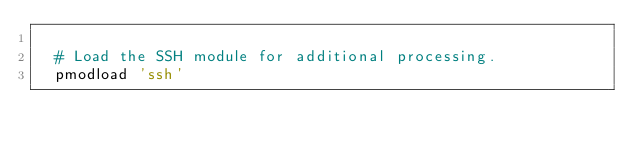Convert code to text. <code><loc_0><loc_0><loc_500><loc_500><_Bash_>
  # Load the SSH module for additional processing.
  pmodload 'ssh'
</code> 